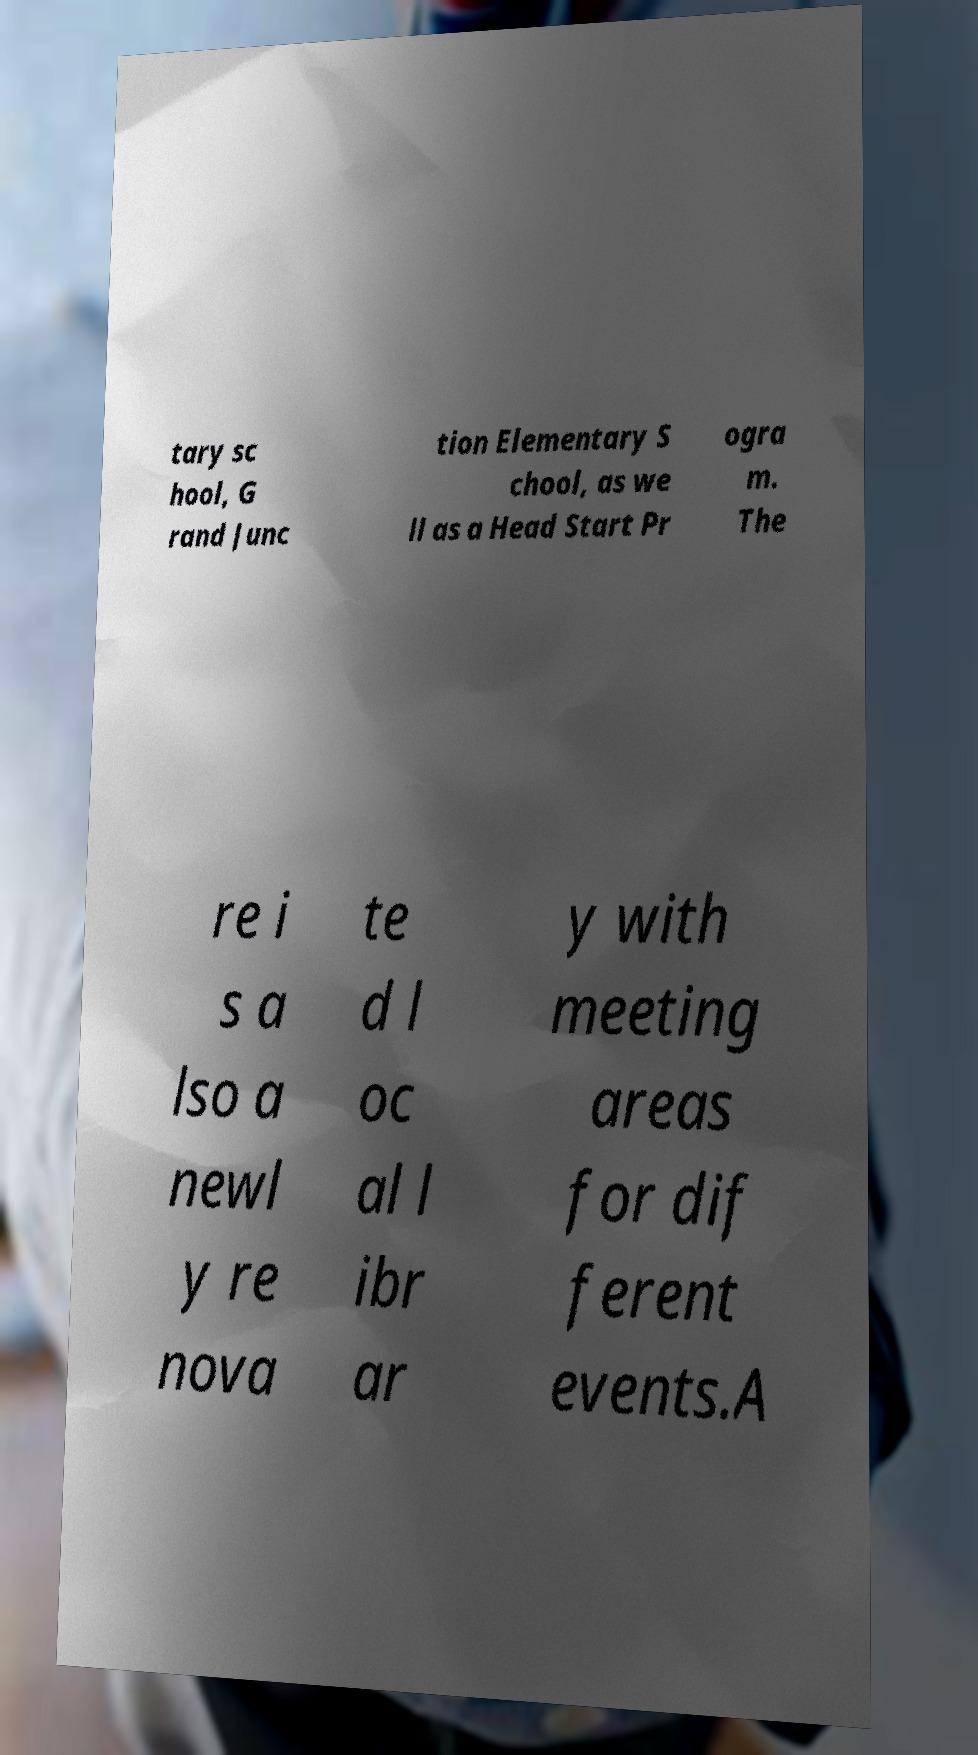Please read and relay the text visible in this image. What does it say? tary sc hool, G rand Junc tion Elementary S chool, as we ll as a Head Start Pr ogra m. The re i s a lso a newl y re nova te d l oc al l ibr ar y with meeting areas for dif ferent events.A 